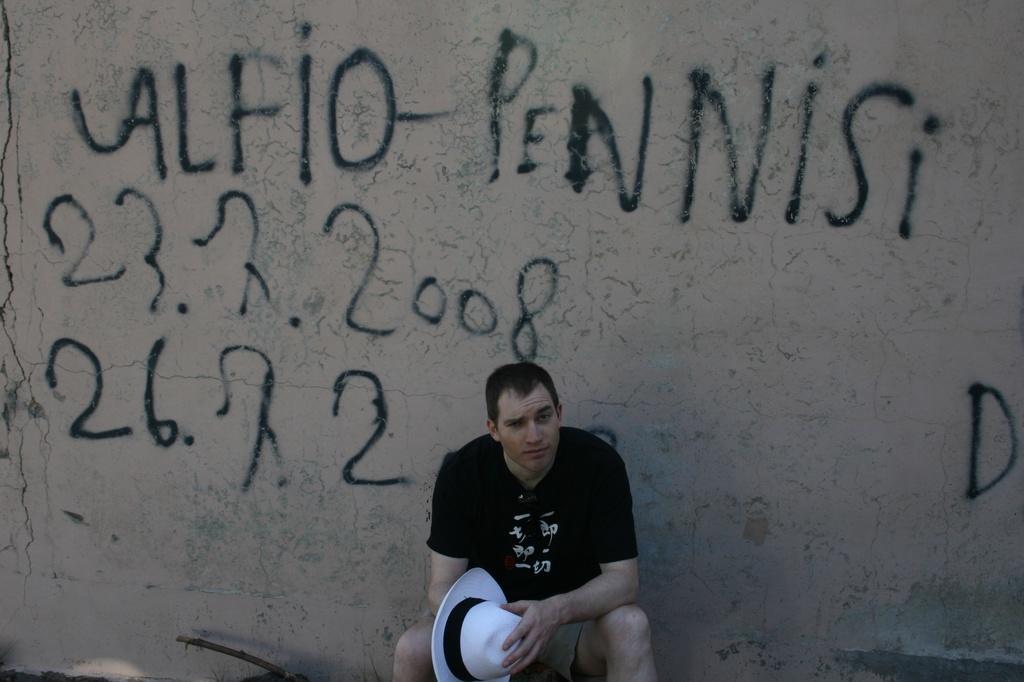Could you give a brief overview of what you see in this image? In this image I can see a person wearing black colored t shirt and holding white and black colored hat is sitting. I can see a wall behind him and on the wall I can see something is written. 